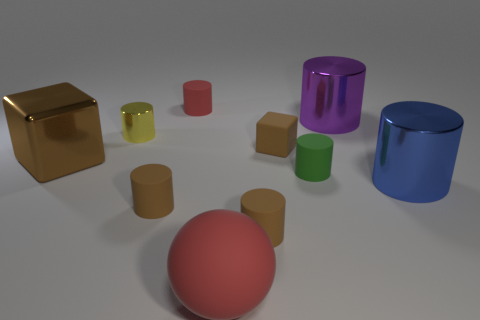Subtract all small green cylinders. How many cylinders are left? 6 Add 3 large blue cylinders. How many large blue cylinders are left? 4 Add 5 purple metallic cubes. How many purple metallic cubes exist? 5 Subtract all red cylinders. How many cylinders are left? 6 Subtract 0 green balls. How many objects are left? 10 Subtract all cubes. How many objects are left? 8 Subtract 2 blocks. How many blocks are left? 0 Subtract all yellow cylinders. Subtract all red cubes. How many cylinders are left? 6 Subtract all blue cubes. How many purple cylinders are left? 1 Subtract all big blocks. Subtract all small cylinders. How many objects are left? 4 